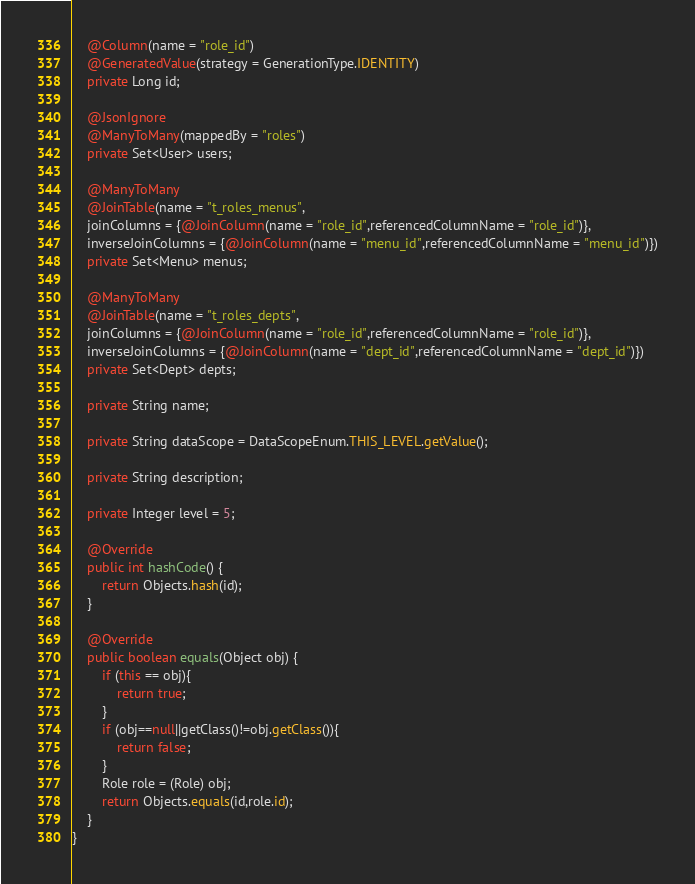<code> <loc_0><loc_0><loc_500><loc_500><_Java_>    @Column(name = "role_id")
    @GeneratedValue(strategy = GenerationType.IDENTITY)
    private Long id;

    @JsonIgnore
    @ManyToMany(mappedBy = "roles")
    private Set<User> users;

    @ManyToMany
    @JoinTable(name = "t_roles_menus",
    joinColumns = {@JoinColumn(name = "role_id",referencedColumnName = "role_id")},
    inverseJoinColumns = {@JoinColumn(name = "menu_id",referencedColumnName = "menu_id")})
    private Set<Menu> menus;

    @ManyToMany
    @JoinTable(name = "t_roles_depts",
    joinColumns = {@JoinColumn(name = "role_id",referencedColumnName = "role_id")},
    inverseJoinColumns = {@JoinColumn(name = "dept_id",referencedColumnName = "dept_id")})
    private Set<Dept> depts;

    private String name;

    private String dataScope = DataScopeEnum.THIS_LEVEL.getValue();

    private String description;

    private Integer level = 5;

    @Override
    public int hashCode() {
        return Objects.hash(id);
    }

    @Override
    public boolean equals(Object obj) {
        if (this == obj){
            return true;
        }
        if (obj==null||getClass()!=obj.getClass()){
            return false;
        }
        Role role = (Role) obj;
        return Objects.equals(id,role.id);
    }
}
</code> 